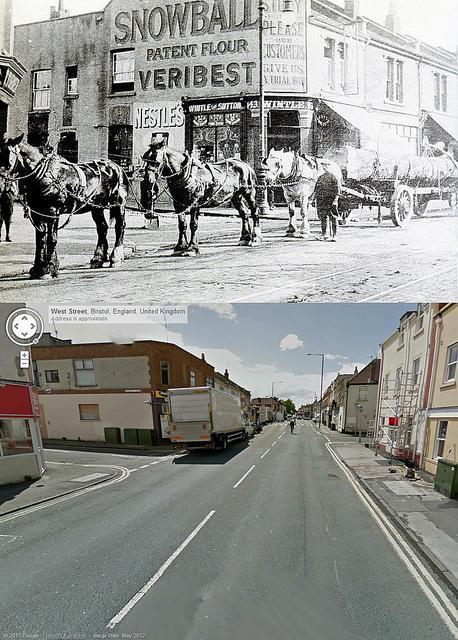How many cars are there?
Give a very brief answer. 0. How many horses are visible?
Give a very brief answer. 3. How many boats are sailing?
Give a very brief answer. 0. 